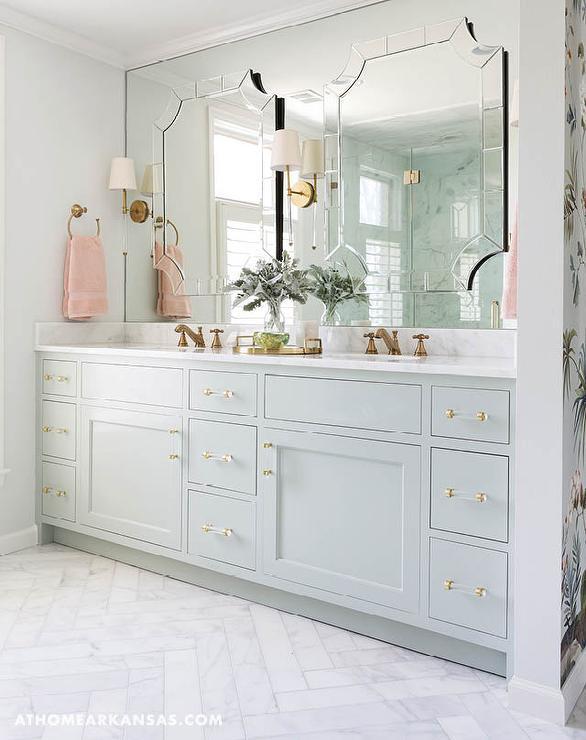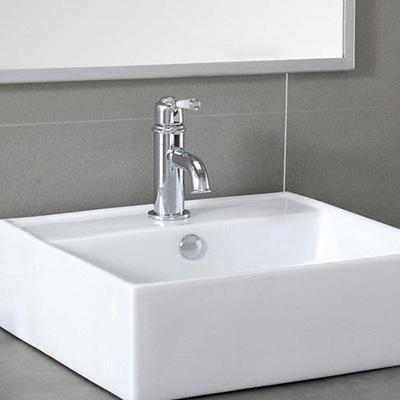The first image is the image on the left, the second image is the image on the right. Given the left and right images, does the statement "Both images feature a single-sink vanity." hold true? Answer yes or no. No. The first image is the image on the left, the second image is the image on the right. Analyze the images presented: Is the assertion "there is a towel in the image on the left." valid? Answer yes or no. Yes. 